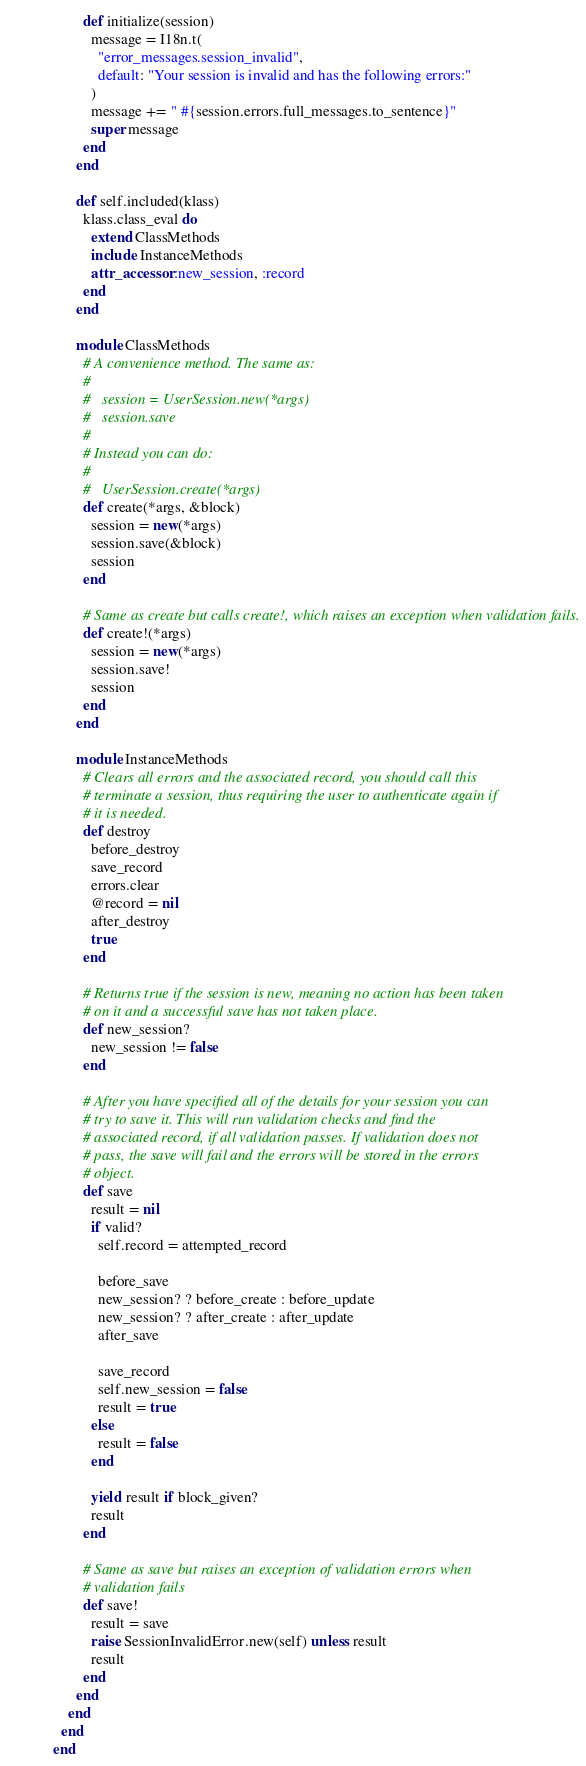Convert code to text. <code><loc_0><loc_0><loc_500><loc_500><_Ruby_>        def initialize(session)
          message = I18n.t(
            "error_messages.session_invalid",
            default: "Your session is invalid and has the following errors:"
          )
          message += " #{session.errors.full_messages.to_sentence}"
          super message
        end
      end

      def self.included(klass)
        klass.class_eval do
          extend ClassMethods
          include InstanceMethods
          attr_accessor :new_session, :record
        end
      end

      module ClassMethods
        # A convenience method. The same as:
        #
        #   session = UserSession.new(*args)
        #   session.save
        #
        # Instead you can do:
        #
        #   UserSession.create(*args)
        def create(*args, &block)
          session = new(*args)
          session.save(&block)
          session
        end

        # Same as create but calls create!, which raises an exception when validation fails.
        def create!(*args)
          session = new(*args)
          session.save!
          session
        end
      end

      module InstanceMethods
        # Clears all errors and the associated record, you should call this
        # terminate a session, thus requiring the user to authenticate again if
        # it is needed.
        def destroy
          before_destroy
          save_record
          errors.clear
          @record = nil
          after_destroy
          true
        end

        # Returns true if the session is new, meaning no action has been taken
        # on it and a successful save has not taken place.
        def new_session?
          new_session != false
        end

        # After you have specified all of the details for your session you can
        # try to save it. This will run validation checks and find the
        # associated record, if all validation passes. If validation does not
        # pass, the save will fail and the errors will be stored in the errors
        # object.
        def save
          result = nil
          if valid?
            self.record = attempted_record

            before_save
            new_session? ? before_create : before_update
            new_session? ? after_create : after_update
            after_save

            save_record
            self.new_session = false
            result = true
          else
            result = false
          end

          yield result if block_given?
          result
        end

        # Same as save but raises an exception of validation errors when
        # validation fails
        def save!
          result = save
          raise SessionInvalidError.new(self) unless result
          result
        end
      end
    end
  end
end
</code> 